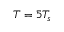Convert formula to latex. <formula><loc_0><loc_0><loc_500><loc_500>T = 5 T _ { s }</formula> 